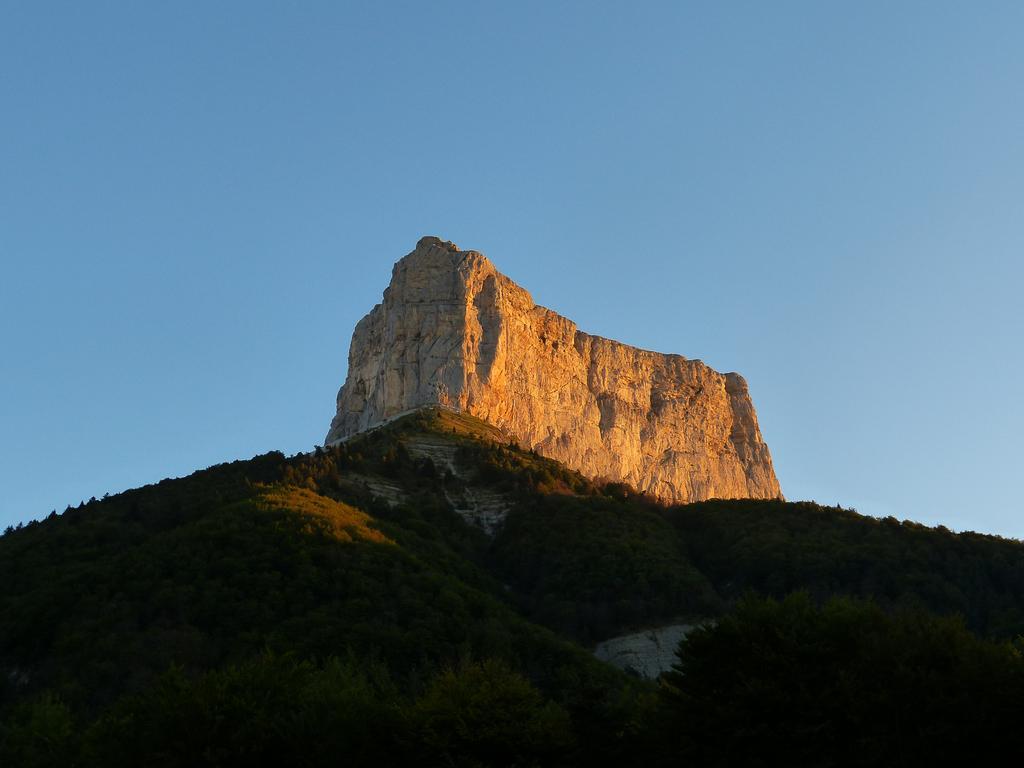Please provide a concise description of this image. In this image we can see a group of trees, mountains and in the background, we can see the sky. 